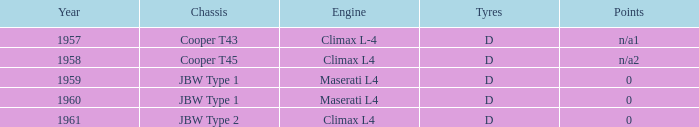What are the tires from a year prior to 1961 for a climax l4 engine? D. 